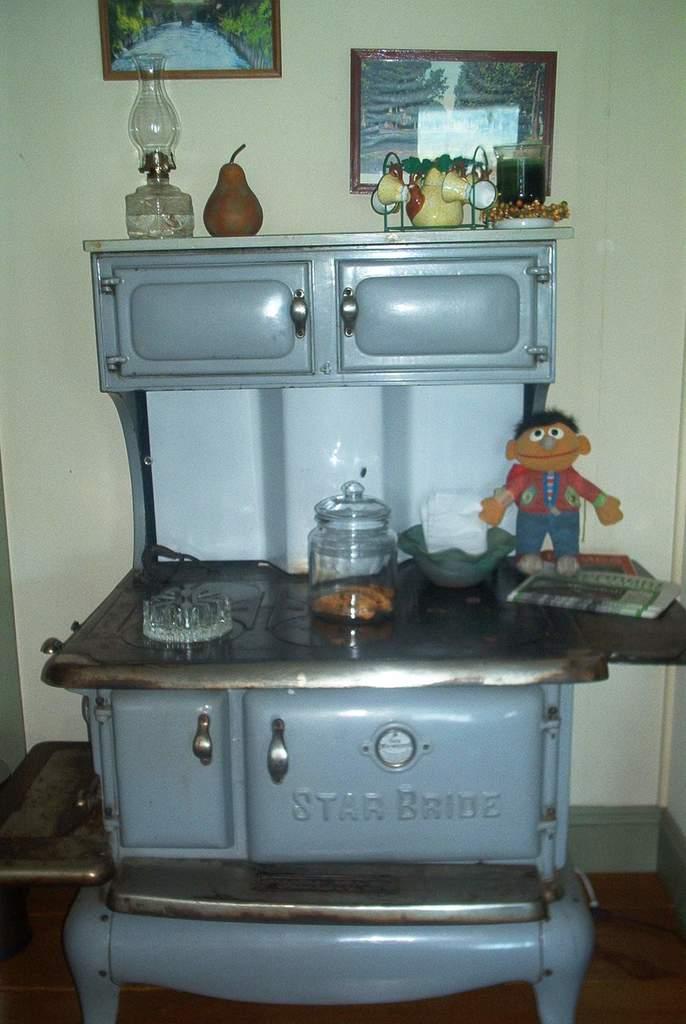What is the brand of that stove?
Your response must be concise. Star bride. 